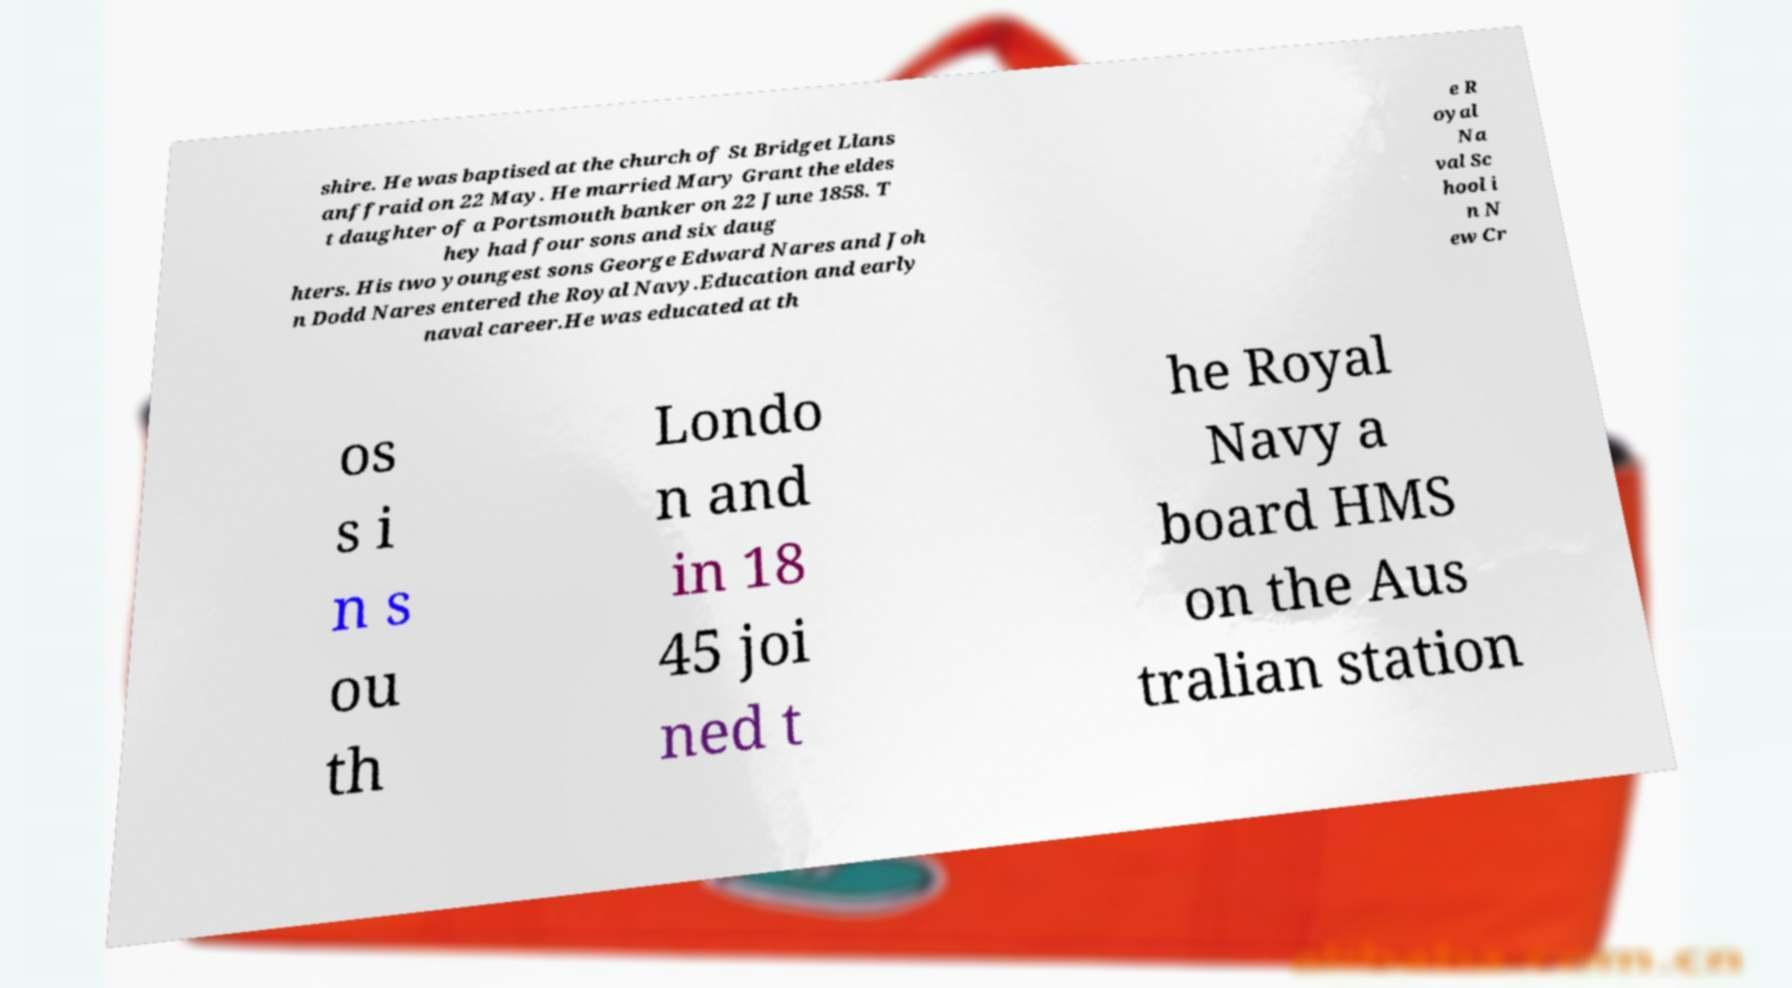Can you read and provide the text displayed in the image?This photo seems to have some interesting text. Can you extract and type it out for me? shire. He was baptised at the church of St Bridget Llans anffraid on 22 May. He married Mary Grant the eldes t daughter of a Portsmouth banker on 22 June 1858. T hey had four sons and six daug hters. His two youngest sons George Edward Nares and Joh n Dodd Nares entered the Royal Navy.Education and early naval career.He was educated at th e R oyal Na val Sc hool i n N ew Cr os s i n s ou th Londo n and in 18 45 joi ned t he Royal Navy a board HMS on the Aus tralian station 